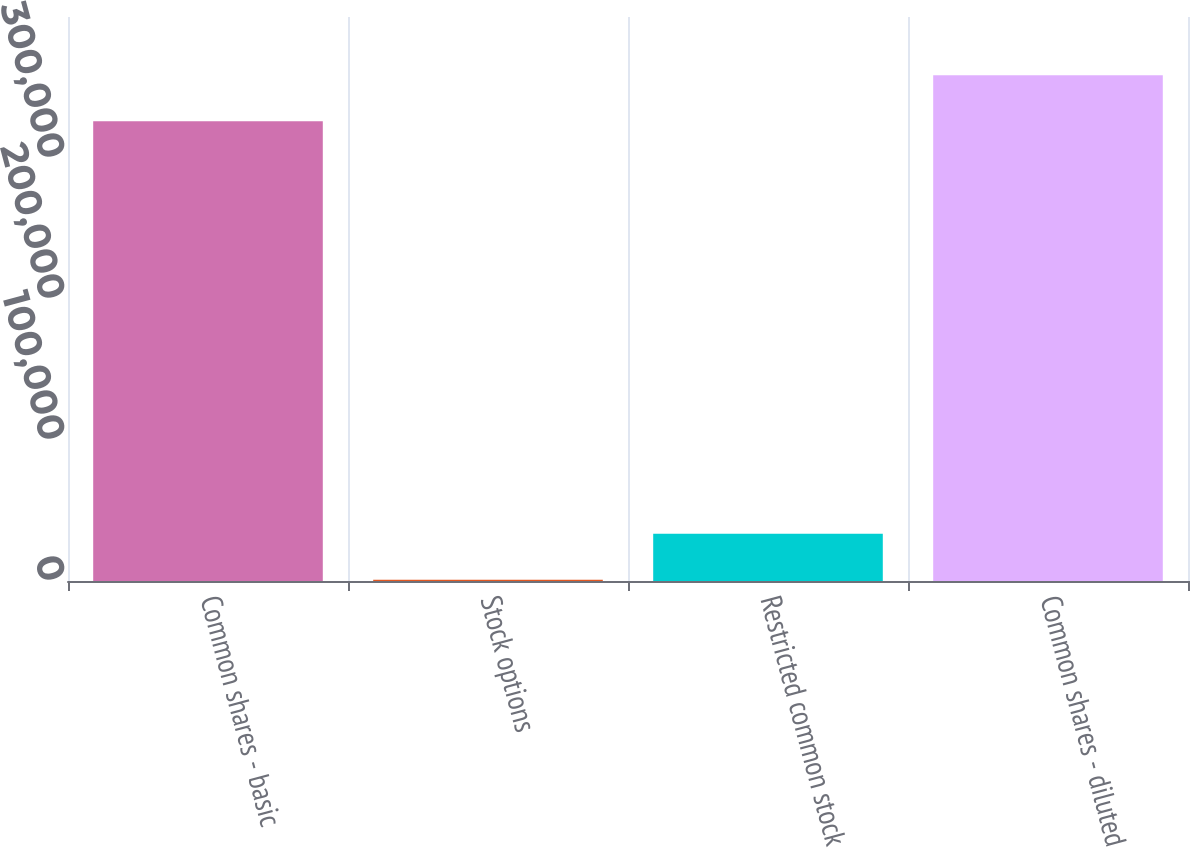Convert chart. <chart><loc_0><loc_0><loc_500><loc_500><bar_chart><fcel>Common shares - basic<fcel>Stock options<fcel>Restricted common stock<fcel>Common shares - diluted<nl><fcel>325999<fcel>829<fcel>33573.8<fcel>358744<nl></chart> 